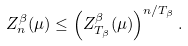Convert formula to latex. <formula><loc_0><loc_0><loc_500><loc_500>Z _ { n } ^ { \beta } ( \mu ) \leq \left ( Z _ { T _ { \beta } } ^ { \beta } ( \mu ) \right ) ^ { n / T _ { \beta } } .</formula> 